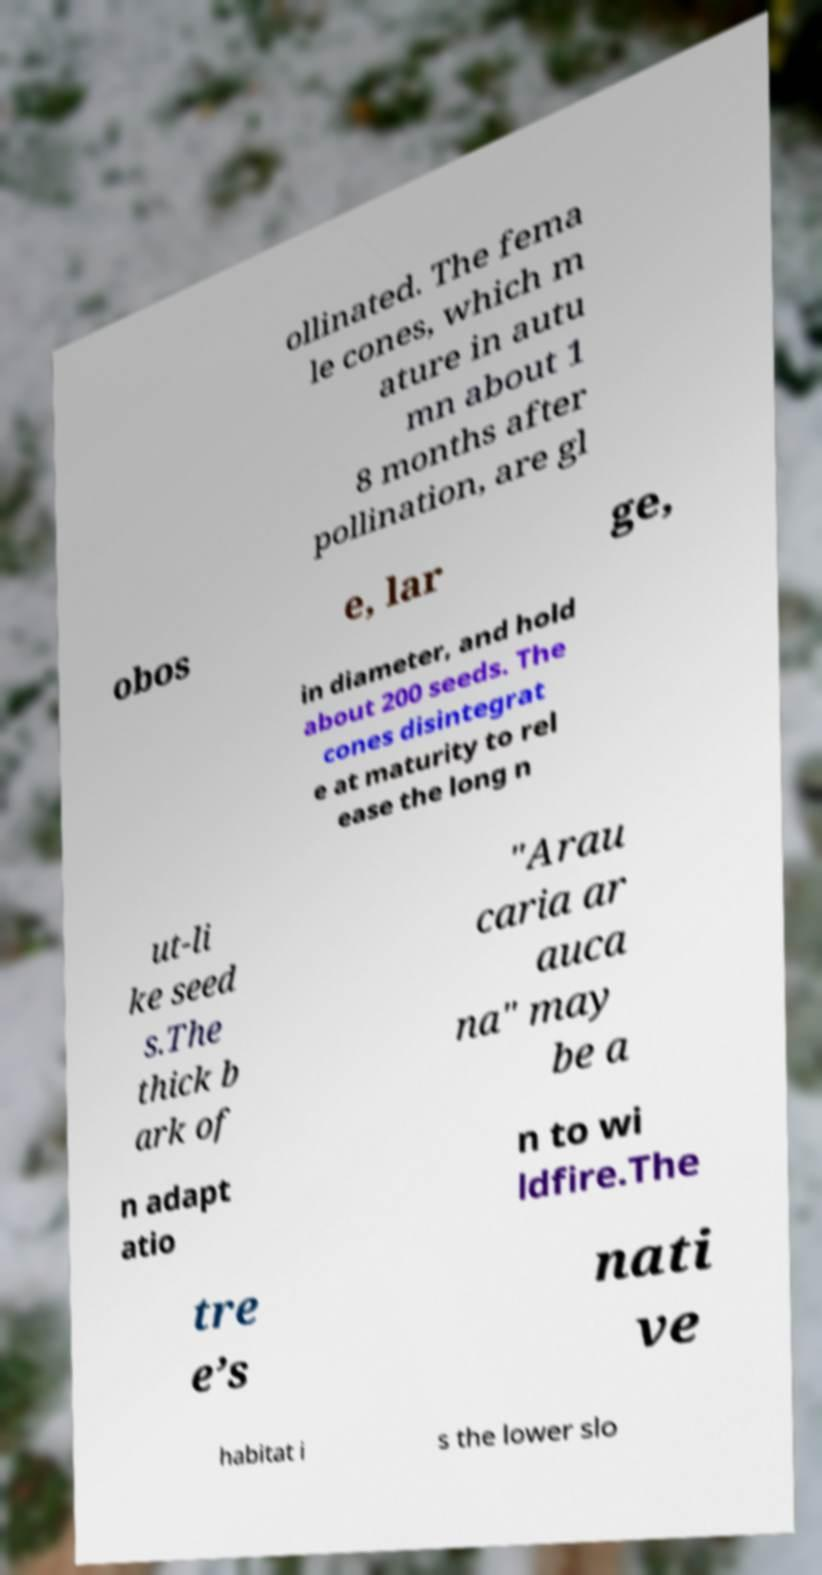Please identify and transcribe the text found in this image. ollinated. The fema le cones, which m ature in autu mn about 1 8 months after pollination, are gl obos e, lar ge, in diameter, and hold about 200 seeds. The cones disintegrat e at maturity to rel ease the long n ut-li ke seed s.The thick b ark of "Arau caria ar auca na" may be a n adapt atio n to wi ldfire.The tre e’s nati ve habitat i s the lower slo 